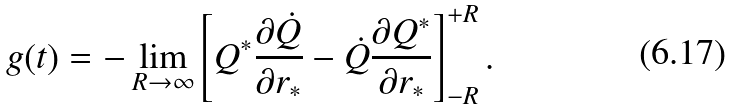Convert formula to latex. <formula><loc_0><loc_0><loc_500><loc_500>g ( t ) = - \lim _ { R \rightarrow \infty } \left [ Q ^ { * } \frac { \partial \dot { Q } } { \partial r _ { * } } - \dot { Q } \frac { \partial Q ^ { * } } { \partial r _ { * } } \right ] _ { - R } ^ { + R } .</formula> 